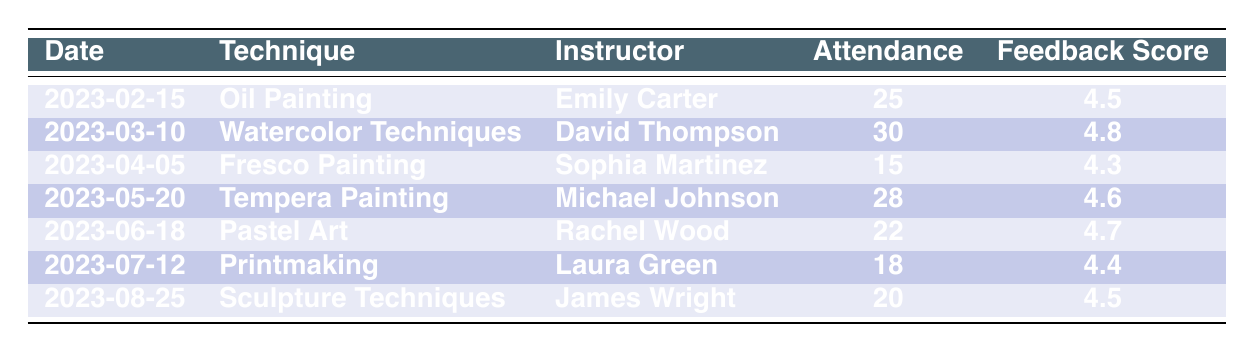What was the highest attendance recorded at a workshop? By examining the attendance column, I can identify the highest attendance figure. The highest is 30, which belongs to the workshop on Watercolor Techniques held on 2023-03-10.
Answer: 30 Who was the instructor for the workshop on Fresco Painting? The table lists the instructors alongside their corresponding workshops. The instructor for Fresco Painting, which took place on 2023-04-05, is Sophia Martinez.
Answer: Sophia Martinez What is the average feedback score of all the workshops? To calculate the average feedback score, I sum the individual scores: (4.5 + 4.8 + 4.3 + 4.6 + 4.7 + 4.4 + 4.5) = 32.8. There are 7 workshops, thus the average is 32.8 / 7 = 4.6857, which can be rounded to 4.7.
Answer: 4.7 Did the workshop with the highest attendance also receive the highest feedback score? The workshop with the highest attendance is Watercolor Techniques, which had an attendance of 30 and a feedback score of 4.8. The next highest attendance (28 for Tempera Painting) has a score of 4.6. Since there are no other workshops with higher attendance that score higher than 4.8, yes, it is the only one with that attendance and the highest feedback score.
Answer: Yes How many workshops had an attendance of less than 20 participants? By reviewing the attendance column, I find the workshops that met this criterion: Fresco Painting had 15, and Printmaking had 18. Thus, there are 2 workshops attended by fewer than 20 participants.
Answer: 2 What was the feedback score for the workshop on Oil Painting? The feedback score for the Oil Painting workshop, held on 2023-02-15, is listed as 4.5 in the feedback score column.
Answer: 4.5 Was there any workshop with an attendance of exactly 25 participants? Checking the attendance column, I see that the Oil Painting workshop indeed has an attendance of exactly 25 participants. Therefore, the answer is yes.
Answer: Yes Which technique had the lowest attendance, and what was that number? Upon examining the attendance data, Fresco Painting holds the lowest attendance figure with 15 participants.
Answer: Fresco Painting, 15 